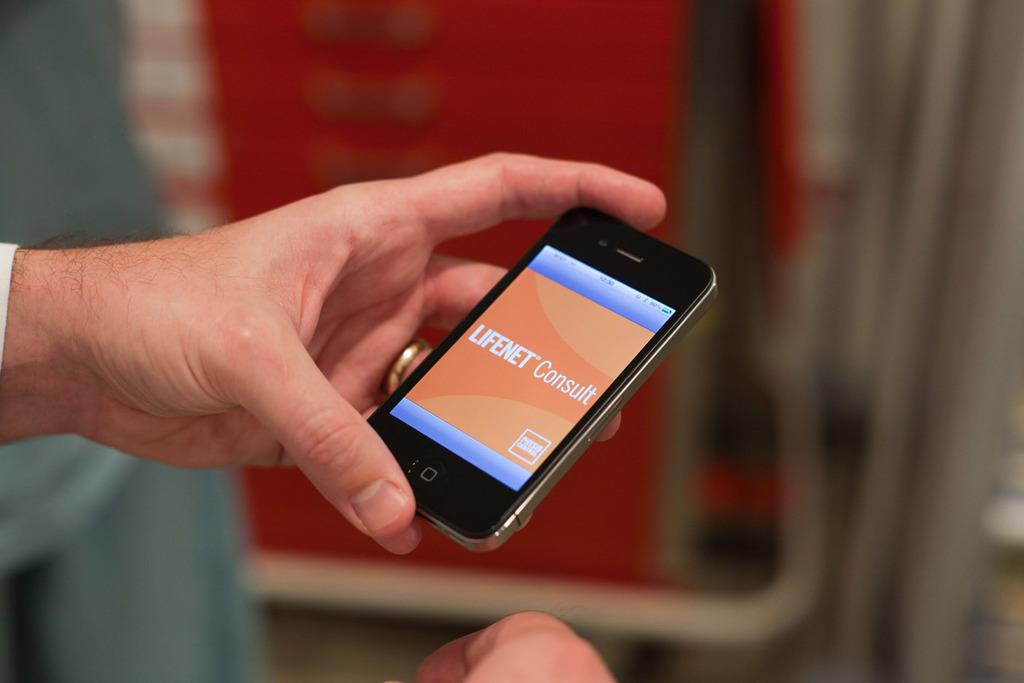<image>
Summarize the visual content of the image. a hand holding a cell phone with the lifenet consult open 